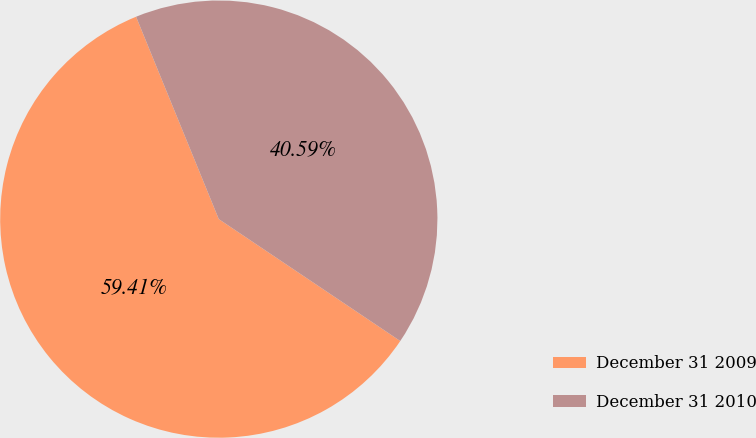<chart> <loc_0><loc_0><loc_500><loc_500><pie_chart><fcel>December 31 2009<fcel>December 31 2010<nl><fcel>59.41%<fcel>40.59%<nl></chart> 